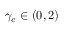Convert formula to latex. <formula><loc_0><loc_0><loc_500><loc_500>\gamma _ { c } \in ( 0 , 2 )</formula> 